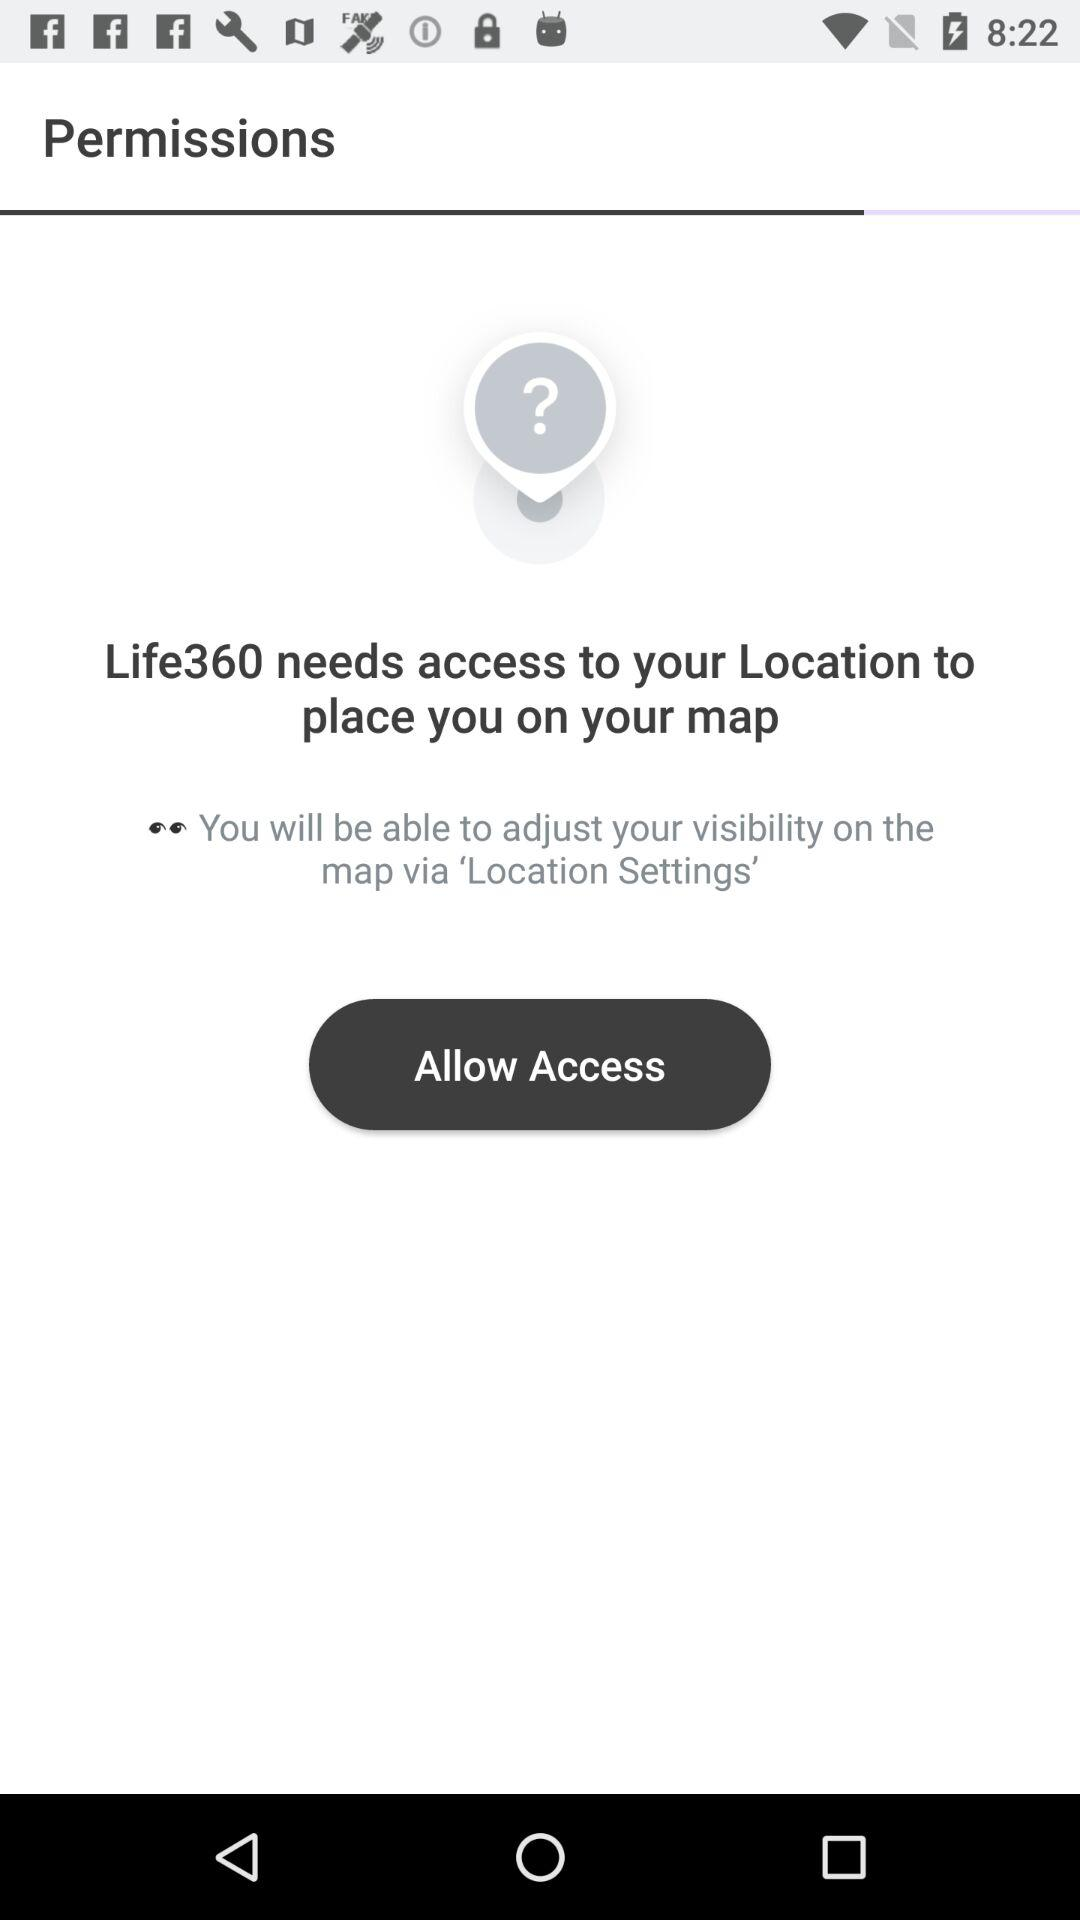What is the application name? The application name is "Life360". 